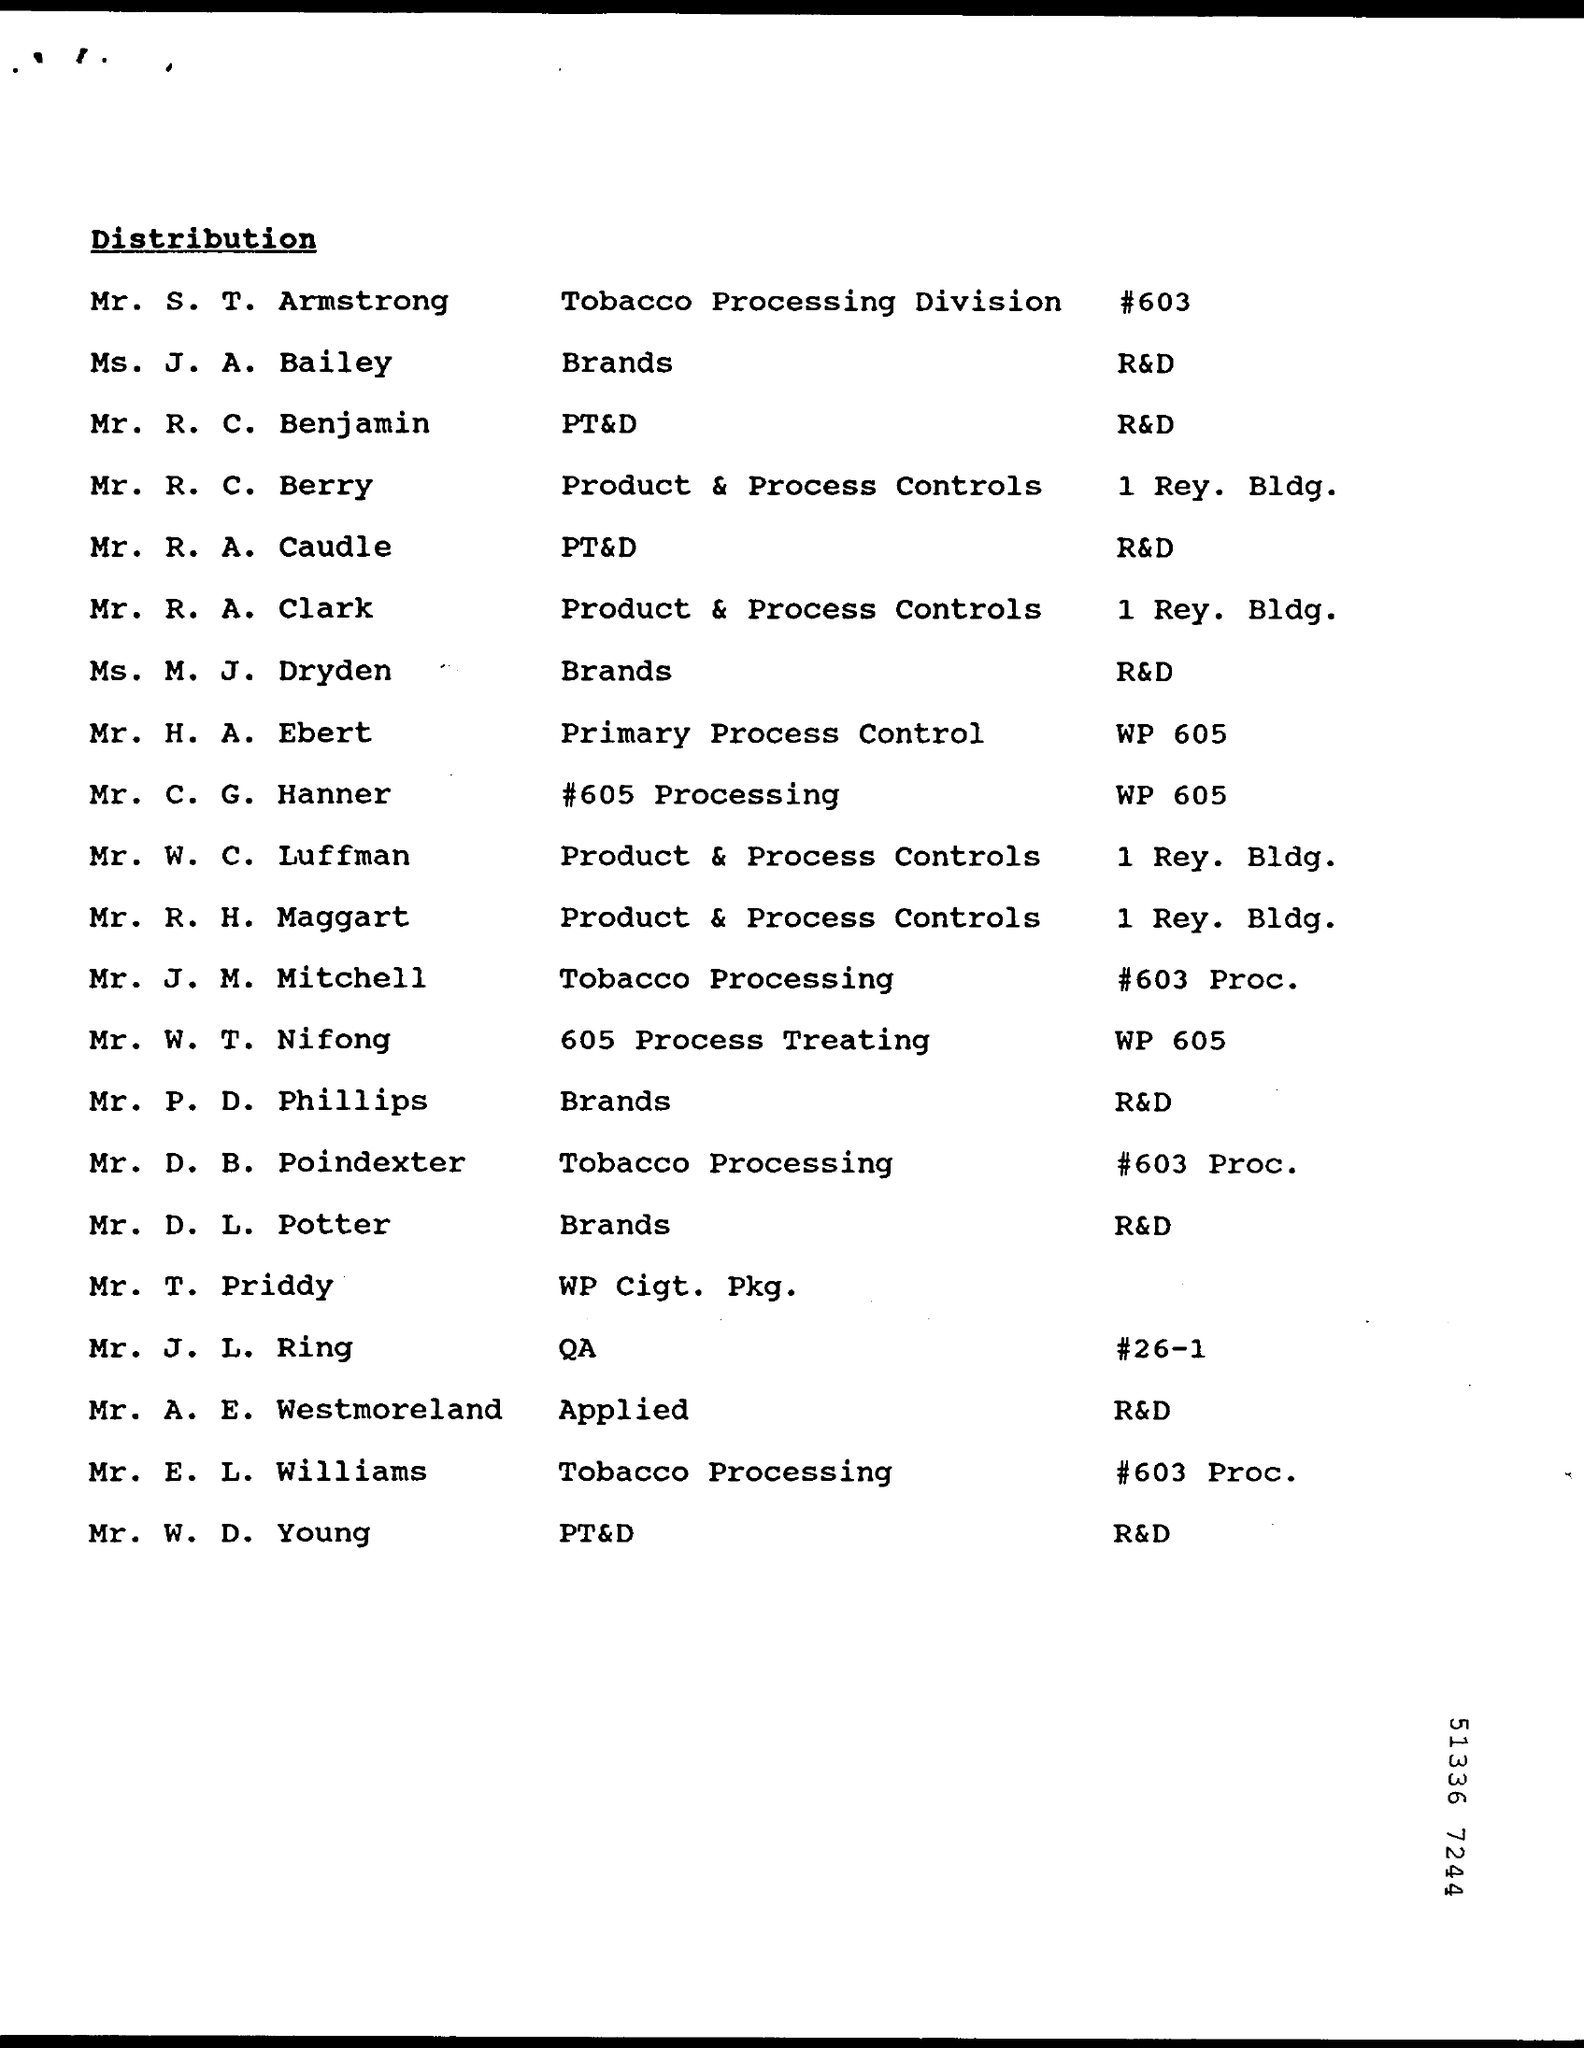Mention a couple of crucial points in this snapshot. Mr. R. A. Clark is responsible for ensuring the proper functioning of product and process controls. The individual responsible for overseeing the Tobacco Processing Division is Mr. S. T. Armstrong. 